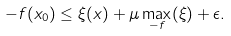<formula> <loc_0><loc_0><loc_500><loc_500>- f ( x _ { 0 } ) \leq \xi ( x ) + \mu \max _ { - f } ( \xi ) + \epsilon .</formula> 